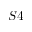<formula> <loc_0><loc_0><loc_500><loc_500>S 4</formula> 